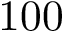<formula> <loc_0><loc_0><loc_500><loc_500>1 0 0</formula> 